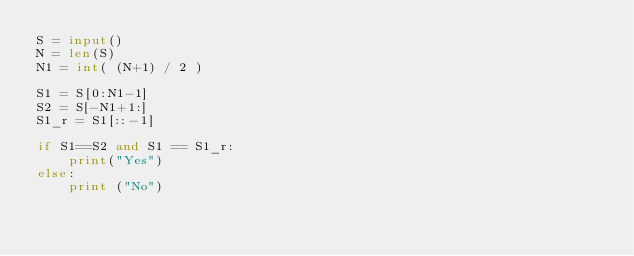<code> <loc_0><loc_0><loc_500><loc_500><_Python_>S = input()
N = len(S)
N1 = int( (N+1) / 2 )

S1 = S[0:N1-1]
S2 = S[-N1+1:]
S1_r = S1[::-1]

if S1==S2 and S1 == S1_r:
    print("Yes")
else:
    print ("No")</code> 